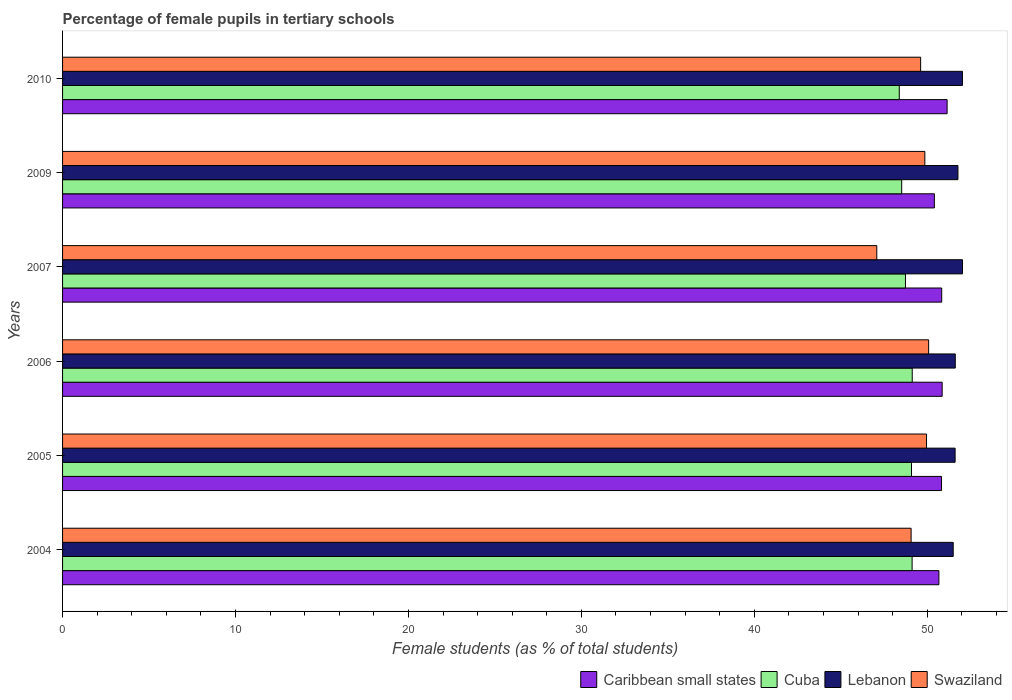How many different coloured bars are there?
Offer a very short reply. 4. How many bars are there on the 4th tick from the bottom?
Provide a succinct answer. 4. In how many cases, is the number of bars for a given year not equal to the number of legend labels?
Provide a succinct answer. 0. What is the percentage of female pupils in tertiary schools in Swaziland in 2006?
Your answer should be very brief. 50.08. Across all years, what is the maximum percentage of female pupils in tertiary schools in Cuba?
Your response must be concise. 49.13. Across all years, what is the minimum percentage of female pupils in tertiary schools in Caribbean small states?
Your answer should be compact. 50.41. In which year was the percentage of female pupils in tertiary schools in Swaziland maximum?
Your answer should be very brief. 2006. What is the total percentage of female pupils in tertiary schools in Lebanon in the graph?
Keep it short and to the point. 310.57. What is the difference between the percentage of female pupils in tertiary schools in Caribbean small states in 2004 and that in 2010?
Keep it short and to the point. -0.47. What is the difference between the percentage of female pupils in tertiary schools in Swaziland in 2010 and the percentage of female pupils in tertiary schools in Cuba in 2005?
Your answer should be compact. 0.53. What is the average percentage of female pupils in tertiary schools in Lebanon per year?
Make the answer very short. 51.76. In the year 2007, what is the difference between the percentage of female pupils in tertiary schools in Cuba and percentage of female pupils in tertiary schools in Caribbean small states?
Provide a short and direct response. -2.09. In how many years, is the percentage of female pupils in tertiary schools in Cuba greater than 36 %?
Offer a very short reply. 6. What is the ratio of the percentage of female pupils in tertiary schools in Caribbean small states in 2005 to that in 2010?
Make the answer very short. 0.99. Is the percentage of female pupils in tertiary schools in Cuba in 2005 less than that in 2010?
Provide a succinct answer. No. Is the difference between the percentage of female pupils in tertiary schools in Cuba in 2009 and 2010 greater than the difference between the percentage of female pupils in tertiary schools in Caribbean small states in 2009 and 2010?
Offer a terse response. Yes. What is the difference between the highest and the second highest percentage of female pupils in tertiary schools in Lebanon?
Offer a very short reply. 0. What is the difference between the highest and the lowest percentage of female pupils in tertiary schools in Swaziland?
Provide a succinct answer. 3. In how many years, is the percentage of female pupils in tertiary schools in Lebanon greater than the average percentage of female pupils in tertiary schools in Lebanon taken over all years?
Your answer should be very brief. 3. Is it the case that in every year, the sum of the percentage of female pupils in tertiary schools in Lebanon and percentage of female pupils in tertiary schools in Caribbean small states is greater than the sum of percentage of female pupils in tertiary schools in Cuba and percentage of female pupils in tertiary schools in Swaziland?
Provide a short and direct response. Yes. What does the 3rd bar from the top in 2005 represents?
Offer a terse response. Cuba. What does the 1st bar from the bottom in 2005 represents?
Give a very brief answer. Caribbean small states. Are all the bars in the graph horizontal?
Give a very brief answer. Yes. How many years are there in the graph?
Your answer should be compact. 6. What is the difference between two consecutive major ticks on the X-axis?
Offer a terse response. 10. Where does the legend appear in the graph?
Offer a very short reply. Bottom right. What is the title of the graph?
Make the answer very short. Percentage of female pupils in tertiary schools. Does "Gambia, The" appear as one of the legend labels in the graph?
Offer a very short reply. No. What is the label or title of the X-axis?
Ensure brevity in your answer.  Female students (as % of total students). What is the label or title of the Y-axis?
Your response must be concise. Years. What is the Female students (as % of total students) of Caribbean small states in 2004?
Your answer should be very brief. 50.67. What is the Female students (as % of total students) in Cuba in 2004?
Your response must be concise. 49.12. What is the Female students (as % of total students) of Lebanon in 2004?
Offer a very short reply. 51.5. What is the Female students (as % of total students) of Swaziland in 2004?
Your answer should be compact. 49.06. What is the Female students (as % of total students) in Caribbean small states in 2005?
Offer a very short reply. 50.82. What is the Female students (as % of total students) in Cuba in 2005?
Ensure brevity in your answer.  49.09. What is the Female students (as % of total students) of Lebanon in 2005?
Give a very brief answer. 51.61. What is the Female students (as % of total students) of Swaziland in 2005?
Ensure brevity in your answer.  49.95. What is the Female students (as % of total students) of Caribbean small states in 2006?
Provide a succinct answer. 50.86. What is the Female students (as % of total students) in Cuba in 2006?
Your answer should be very brief. 49.13. What is the Female students (as % of total students) of Lebanon in 2006?
Your response must be concise. 51.62. What is the Female students (as % of total students) in Swaziland in 2006?
Give a very brief answer. 50.08. What is the Female students (as % of total students) of Caribbean small states in 2007?
Your answer should be very brief. 50.83. What is the Female students (as % of total students) in Cuba in 2007?
Offer a terse response. 48.74. What is the Female students (as % of total students) of Lebanon in 2007?
Make the answer very short. 52.04. What is the Female students (as % of total students) of Swaziland in 2007?
Give a very brief answer. 47.08. What is the Female students (as % of total students) of Caribbean small states in 2009?
Make the answer very short. 50.41. What is the Female students (as % of total students) in Cuba in 2009?
Your answer should be compact. 48.52. What is the Female students (as % of total students) in Lebanon in 2009?
Keep it short and to the point. 51.77. What is the Female students (as % of total students) of Swaziland in 2009?
Your answer should be compact. 49.86. What is the Female students (as % of total students) in Caribbean small states in 2010?
Provide a short and direct response. 51.15. What is the Female students (as % of total students) in Cuba in 2010?
Give a very brief answer. 48.38. What is the Female students (as % of total students) of Lebanon in 2010?
Give a very brief answer. 52.03. What is the Female students (as % of total students) of Swaziland in 2010?
Make the answer very short. 49.62. Across all years, what is the maximum Female students (as % of total students) of Caribbean small states?
Make the answer very short. 51.15. Across all years, what is the maximum Female students (as % of total students) of Cuba?
Provide a short and direct response. 49.13. Across all years, what is the maximum Female students (as % of total students) in Lebanon?
Ensure brevity in your answer.  52.04. Across all years, what is the maximum Female students (as % of total students) in Swaziland?
Offer a terse response. 50.08. Across all years, what is the minimum Female students (as % of total students) of Caribbean small states?
Give a very brief answer. 50.41. Across all years, what is the minimum Female students (as % of total students) in Cuba?
Make the answer very short. 48.38. Across all years, what is the minimum Female students (as % of total students) in Lebanon?
Give a very brief answer. 51.5. Across all years, what is the minimum Female students (as % of total students) in Swaziland?
Keep it short and to the point. 47.08. What is the total Female students (as % of total students) in Caribbean small states in the graph?
Make the answer very short. 304.75. What is the total Female students (as % of total students) in Cuba in the graph?
Ensure brevity in your answer.  292.98. What is the total Female students (as % of total students) of Lebanon in the graph?
Your response must be concise. 310.57. What is the total Female students (as % of total students) of Swaziland in the graph?
Provide a succinct answer. 295.66. What is the difference between the Female students (as % of total students) in Caribbean small states in 2004 and that in 2005?
Provide a succinct answer. -0.15. What is the difference between the Female students (as % of total students) in Cuba in 2004 and that in 2005?
Give a very brief answer. 0.04. What is the difference between the Female students (as % of total students) of Lebanon in 2004 and that in 2005?
Your answer should be compact. -0.11. What is the difference between the Female students (as % of total students) in Swaziland in 2004 and that in 2005?
Offer a terse response. -0.89. What is the difference between the Female students (as % of total students) of Caribbean small states in 2004 and that in 2006?
Provide a succinct answer. -0.19. What is the difference between the Female students (as % of total students) in Cuba in 2004 and that in 2006?
Your response must be concise. -0.01. What is the difference between the Female students (as % of total students) in Lebanon in 2004 and that in 2006?
Keep it short and to the point. -0.12. What is the difference between the Female students (as % of total students) in Swaziland in 2004 and that in 2006?
Provide a short and direct response. -1.01. What is the difference between the Female students (as % of total students) in Caribbean small states in 2004 and that in 2007?
Make the answer very short. -0.16. What is the difference between the Female students (as % of total students) of Cuba in 2004 and that in 2007?
Make the answer very short. 0.38. What is the difference between the Female students (as % of total students) of Lebanon in 2004 and that in 2007?
Provide a succinct answer. -0.54. What is the difference between the Female students (as % of total students) in Swaziland in 2004 and that in 2007?
Give a very brief answer. 1.98. What is the difference between the Female students (as % of total students) in Caribbean small states in 2004 and that in 2009?
Ensure brevity in your answer.  0.26. What is the difference between the Female students (as % of total students) in Cuba in 2004 and that in 2009?
Offer a very short reply. 0.6. What is the difference between the Female students (as % of total students) in Lebanon in 2004 and that in 2009?
Offer a terse response. -0.27. What is the difference between the Female students (as % of total students) in Swaziland in 2004 and that in 2009?
Your answer should be compact. -0.79. What is the difference between the Female students (as % of total students) in Caribbean small states in 2004 and that in 2010?
Give a very brief answer. -0.47. What is the difference between the Female students (as % of total students) of Cuba in 2004 and that in 2010?
Offer a very short reply. 0.74. What is the difference between the Female students (as % of total students) of Lebanon in 2004 and that in 2010?
Ensure brevity in your answer.  -0.53. What is the difference between the Female students (as % of total students) in Swaziland in 2004 and that in 2010?
Give a very brief answer. -0.55. What is the difference between the Female students (as % of total students) in Caribbean small states in 2005 and that in 2006?
Provide a short and direct response. -0.04. What is the difference between the Female students (as % of total students) of Cuba in 2005 and that in 2006?
Your answer should be very brief. -0.04. What is the difference between the Female students (as % of total students) in Lebanon in 2005 and that in 2006?
Ensure brevity in your answer.  -0.01. What is the difference between the Female students (as % of total students) of Swaziland in 2005 and that in 2006?
Offer a very short reply. -0.12. What is the difference between the Female students (as % of total students) of Caribbean small states in 2005 and that in 2007?
Your answer should be very brief. -0.01. What is the difference between the Female students (as % of total students) in Cuba in 2005 and that in 2007?
Make the answer very short. 0.35. What is the difference between the Female students (as % of total students) of Lebanon in 2005 and that in 2007?
Offer a terse response. -0.43. What is the difference between the Female students (as % of total students) in Swaziland in 2005 and that in 2007?
Provide a succinct answer. 2.87. What is the difference between the Female students (as % of total students) in Caribbean small states in 2005 and that in 2009?
Provide a succinct answer. 0.41. What is the difference between the Female students (as % of total students) in Cuba in 2005 and that in 2009?
Give a very brief answer. 0.57. What is the difference between the Female students (as % of total students) in Lebanon in 2005 and that in 2009?
Keep it short and to the point. -0.16. What is the difference between the Female students (as % of total students) in Swaziland in 2005 and that in 2009?
Keep it short and to the point. 0.1. What is the difference between the Female students (as % of total students) in Caribbean small states in 2005 and that in 2010?
Offer a very short reply. -0.32. What is the difference between the Female students (as % of total students) in Cuba in 2005 and that in 2010?
Your response must be concise. 0.71. What is the difference between the Female students (as % of total students) of Lebanon in 2005 and that in 2010?
Make the answer very short. -0.42. What is the difference between the Female students (as % of total students) in Swaziland in 2005 and that in 2010?
Your response must be concise. 0.34. What is the difference between the Female students (as % of total students) in Caribbean small states in 2006 and that in 2007?
Provide a short and direct response. 0.03. What is the difference between the Female students (as % of total students) of Cuba in 2006 and that in 2007?
Give a very brief answer. 0.39. What is the difference between the Female students (as % of total students) in Lebanon in 2006 and that in 2007?
Provide a succinct answer. -0.42. What is the difference between the Female students (as % of total students) of Swaziland in 2006 and that in 2007?
Your answer should be very brief. 3. What is the difference between the Female students (as % of total students) of Caribbean small states in 2006 and that in 2009?
Offer a terse response. 0.45. What is the difference between the Female students (as % of total students) in Cuba in 2006 and that in 2009?
Keep it short and to the point. 0.61. What is the difference between the Female students (as % of total students) of Lebanon in 2006 and that in 2009?
Make the answer very short. -0.15. What is the difference between the Female students (as % of total students) in Swaziland in 2006 and that in 2009?
Make the answer very short. 0.22. What is the difference between the Female students (as % of total students) of Caribbean small states in 2006 and that in 2010?
Keep it short and to the point. -0.29. What is the difference between the Female students (as % of total students) in Cuba in 2006 and that in 2010?
Your response must be concise. 0.75. What is the difference between the Female students (as % of total students) of Lebanon in 2006 and that in 2010?
Your response must be concise. -0.41. What is the difference between the Female students (as % of total students) in Swaziland in 2006 and that in 2010?
Make the answer very short. 0.46. What is the difference between the Female students (as % of total students) of Caribbean small states in 2007 and that in 2009?
Your response must be concise. 0.42. What is the difference between the Female students (as % of total students) of Cuba in 2007 and that in 2009?
Your answer should be very brief. 0.22. What is the difference between the Female students (as % of total students) in Lebanon in 2007 and that in 2009?
Make the answer very short. 0.26. What is the difference between the Female students (as % of total students) of Swaziland in 2007 and that in 2009?
Your answer should be compact. -2.78. What is the difference between the Female students (as % of total students) of Caribbean small states in 2007 and that in 2010?
Provide a succinct answer. -0.31. What is the difference between the Female students (as % of total students) in Cuba in 2007 and that in 2010?
Keep it short and to the point. 0.36. What is the difference between the Female students (as % of total students) of Lebanon in 2007 and that in 2010?
Give a very brief answer. 0. What is the difference between the Female students (as % of total students) in Swaziland in 2007 and that in 2010?
Ensure brevity in your answer.  -2.53. What is the difference between the Female students (as % of total students) of Caribbean small states in 2009 and that in 2010?
Make the answer very short. -0.74. What is the difference between the Female students (as % of total students) in Cuba in 2009 and that in 2010?
Give a very brief answer. 0.14. What is the difference between the Female students (as % of total students) of Lebanon in 2009 and that in 2010?
Keep it short and to the point. -0.26. What is the difference between the Female students (as % of total students) of Swaziland in 2009 and that in 2010?
Provide a short and direct response. 0.24. What is the difference between the Female students (as % of total students) of Caribbean small states in 2004 and the Female students (as % of total students) of Cuba in 2005?
Provide a short and direct response. 1.58. What is the difference between the Female students (as % of total students) in Caribbean small states in 2004 and the Female students (as % of total students) in Lebanon in 2005?
Keep it short and to the point. -0.94. What is the difference between the Female students (as % of total students) in Caribbean small states in 2004 and the Female students (as % of total students) in Swaziland in 2005?
Make the answer very short. 0.72. What is the difference between the Female students (as % of total students) of Cuba in 2004 and the Female students (as % of total students) of Lebanon in 2005?
Your answer should be very brief. -2.49. What is the difference between the Female students (as % of total students) of Cuba in 2004 and the Female students (as % of total students) of Swaziland in 2005?
Your answer should be very brief. -0.83. What is the difference between the Female students (as % of total students) of Lebanon in 2004 and the Female students (as % of total students) of Swaziland in 2005?
Keep it short and to the point. 1.54. What is the difference between the Female students (as % of total students) in Caribbean small states in 2004 and the Female students (as % of total students) in Cuba in 2006?
Provide a succinct answer. 1.54. What is the difference between the Female students (as % of total students) of Caribbean small states in 2004 and the Female students (as % of total students) of Lebanon in 2006?
Give a very brief answer. -0.95. What is the difference between the Female students (as % of total students) of Caribbean small states in 2004 and the Female students (as % of total students) of Swaziland in 2006?
Ensure brevity in your answer.  0.59. What is the difference between the Female students (as % of total students) of Cuba in 2004 and the Female students (as % of total students) of Lebanon in 2006?
Offer a terse response. -2.5. What is the difference between the Female students (as % of total students) in Cuba in 2004 and the Female students (as % of total students) in Swaziland in 2006?
Your answer should be very brief. -0.96. What is the difference between the Female students (as % of total students) in Lebanon in 2004 and the Female students (as % of total students) in Swaziland in 2006?
Provide a succinct answer. 1.42. What is the difference between the Female students (as % of total students) of Caribbean small states in 2004 and the Female students (as % of total students) of Cuba in 2007?
Offer a very short reply. 1.93. What is the difference between the Female students (as % of total students) in Caribbean small states in 2004 and the Female students (as % of total students) in Lebanon in 2007?
Your answer should be very brief. -1.36. What is the difference between the Female students (as % of total students) in Caribbean small states in 2004 and the Female students (as % of total students) in Swaziland in 2007?
Offer a very short reply. 3.59. What is the difference between the Female students (as % of total students) in Cuba in 2004 and the Female students (as % of total students) in Lebanon in 2007?
Provide a short and direct response. -2.91. What is the difference between the Female students (as % of total students) in Cuba in 2004 and the Female students (as % of total students) in Swaziland in 2007?
Your response must be concise. 2.04. What is the difference between the Female students (as % of total students) in Lebanon in 2004 and the Female students (as % of total students) in Swaziland in 2007?
Your answer should be compact. 4.42. What is the difference between the Female students (as % of total students) in Caribbean small states in 2004 and the Female students (as % of total students) in Cuba in 2009?
Your answer should be very brief. 2.15. What is the difference between the Female students (as % of total students) in Caribbean small states in 2004 and the Female students (as % of total students) in Lebanon in 2009?
Ensure brevity in your answer.  -1.1. What is the difference between the Female students (as % of total students) in Caribbean small states in 2004 and the Female students (as % of total students) in Swaziland in 2009?
Ensure brevity in your answer.  0.81. What is the difference between the Female students (as % of total students) in Cuba in 2004 and the Female students (as % of total students) in Lebanon in 2009?
Provide a short and direct response. -2.65. What is the difference between the Female students (as % of total students) of Cuba in 2004 and the Female students (as % of total students) of Swaziland in 2009?
Your answer should be compact. -0.74. What is the difference between the Female students (as % of total students) of Lebanon in 2004 and the Female students (as % of total students) of Swaziland in 2009?
Provide a succinct answer. 1.64. What is the difference between the Female students (as % of total students) in Caribbean small states in 2004 and the Female students (as % of total students) in Cuba in 2010?
Offer a terse response. 2.29. What is the difference between the Female students (as % of total students) of Caribbean small states in 2004 and the Female students (as % of total students) of Lebanon in 2010?
Give a very brief answer. -1.36. What is the difference between the Female students (as % of total students) in Caribbean small states in 2004 and the Female students (as % of total students) in Swaziland in 2010?
Your answer should be compact. 1.06. What is the difference between the Female students (as % of total students) in Cuba in 2004 and the Female students (as % of total students) in Lebanon in 2010?
Your answer should be compact. -2.91. What is the difference between the Female students (as % of total students) of Cuba in 2004 and the Female students (as % of total students) of Swaziland in 2010?
Provide a short and direct response. -0.49. What is the difference between the Female students (as % of total students) of Lebanon in 2004 and the Female students (as % of total students) of Swaziland in 2010?
Your answer should be very brief. 1.88. What is the difference between the Female students (as % of total students) in Caribbean small states in 2005 and the Female students (as % of total students) in Cuba in 2006?
Your answer should be compact. 1.69. What is the difference between the Female students (as % of total students) in Caribbean small states in 2005 and the Female students (as % of total students) in Lebanon in 2006?
Provide a short and direct response. -0.8. What is the difference between the Female students (as % of total students) of Caribbean small states in 2005 and the Female students (as % of total students) of Swaziland in 2006?
Your answer should be compact. 0.74. What is the difference between the Female students (as % of total students) of Cuba in 2005 and the Female students (as % of total students) of Lebanon in 2006?
Give a very brief answer. -2.53. What is the difference between the Female students (as % of total students) of Cuba in 2005 and the Female students (as % of total students) of Swaziland in 2006?
Provide a succinct answer. -0.99. What is the difference between the Female students (as % of total students) in Lebanon in 2005 and the Female students (as % of total students) in Swaziland in 2006?
Offer a very short reply. 1.53. What is the difference between the Female students (as % of total students) of Caribbean small states in 2005 and the Female students (as % of total students) of Cuba in 2007?
Offer a very short reply. 2.08. What is the difference between the Female students (as % of total students) of Caribbean small states in 2005 and the Female students (as % of total students) of Lebanon in 2007?
Your answer should be very brief. -1.21. What is the difference between the Female students (as % of total students) in Caribbean small states in 2005 and the Female students (as % of total students) in Swaziland in 2007?
Offer a very short reply. 3.74. What is the difference between the Female students (as % of total students) in Cuba in 2005 and the Female students (as % of total students) in Lebanon in 2007?
Keep it short and to the point. -2.95. What is the difference between the Female students (as % of total students) in Cuba in 2005 and the Female students (as % of total students) in Swaziland in 2007?
Make the answer very short. 2.01. What is the difference between the Female students (as % of total students) of Lebanon in 2005 and the Female students (as % of total students) of Swaziland in 2007?
Your answer should be compact. 4.53. What is the difference between the Female students (as % of total students) in Caribbean small states in 2005 and the Female students (as % of total students) in Cuba in 2009?
Make the answer very short. 2.3. What is the difference between the Female students (as % of total students) of Caribbean small states in 2005 and the Female students (as % of total students) of Lebanon in 2009?
Your answer should be compact. -0.95. What is the difference between the Female students (as % of total students) of Cuba in 2005 and the Female students (as % of total students) of Lebanon in 2009?
Ensure brevity in your answer.  -2.69. What is the difference between the Female students (as % of total students) of Cuba in 2005 and the Female students (as % of total students) of Swaziland in 2009?
Your response must be concise. -0.77. What is the difference between the Female students (as % of total students) in Lebanon in 2005 and the Female students (as % of total students) in Swaziland in 2009?
Your answer should be very brief. 1.75. What is the difference between the Female students (as % of total students) of Caribbean small states in 2005 and the Female students (as % of total students) of Cuba in 2010?
Keep it short and to the point. 2.44. What is the difference between the Female students (as % of total students) of Caribbean small states in 2005 and the Female students (as % of total students) of Lebanon in 2010?
Provide a succinct answer. -1.21. What is the difference between the Female students (as % of total students) in Caribbean small states in 2005 and the Female students (as % of total students) in Swaziland in 2010?
Offer a very short reply. 1.21. What is the difference between the Female students (as % of total students) of Cuba in 2005 and the Female students (as % of total students) of Lebanon in 2010?
Keep it short and to the point. -2.95. What is the difference between the Female students (as % of total students) in Cuba in 2005 and the Female students (as % of total students) in Swaziland in 2010?
Provide a short and direct response. -0.53. What is the difference between the Female students (as % of total students) in Lebanon in 2005 and the Female students (as % of total students) in Swaziland in 2010?
Offer a very short reply. 1.99. What is the difference between the Female students (as % of total students) in Caribbean small states in 2006 and the Female students (as % of total students) in Cuba in 2007?
Your response must be concise. 2.12. What is the difference between the Female students (as % of total students) in Caribbean small states in 2006 and the Female students (as % of total students) in Lebanon in 2007?
Your response must be concise. -1.18. What is the difference between the Female students (as % of total students) in Caribbean small states in 2006 and the Female students (as % of total students) in Swaziland in 2007?
Give a very brief answer. 3.78. What is the difference between the Female students (as % of total students) in Cuba in 2006 and the Female students (as % of total students) in Lebanon in 2007?
Provide a short and direct response. -2.91. What is the difference between the Female students (as % of total students) of Cuba in 2006 and the Female students (as % of total students) of Swaziland in 2007?
Give a very brief answer. 2.05. What is the difference between the Female students (as % of total students) of Lebanon in 2006 and the Female students (as % of total students) of Swaziland in 2007?
Provide a succinct answer. 4.54. What is the difference between the Female students (as % of total students) in Caribbean small states in 2006 and the Female students (as % of total students) in Cuba in 2009?
Your response must be concise. 2.34. What is the difference between the Female students (as % of total students) in Caribbean small states in 2006 and the Female students (as % of total students) in Lebanon in 2009?
Provide a short and direct response. -0.91. What is the difference between the Female students (as % of total students) in Cuba in 2006 and the Female students (as % of total students) in Lebanon in 2009?
Make the answer very short. -2.64. What is the difference between the Female students (as % of total students) of Cuba in 2006 and the Female students (as % of total students) of Swaziland in 2009?
Keep it short and to the point. -0.73. What is the difference between the Female students (as % of total students) in Lebanon in 2006 and the Female students (as % of total students) in Swaziland in 2009?
Ensure brevity in your answer.  1.76. What is the difference between the Female students (as % of total students) in Caribbean small states in 2006 and the Female students (as % of total students) in Cuba in 2010?
Your answer should be compact. 2.48. What is the difference between the Female students (as % of total students) of Caribbean small states in 2006 and the Female students (as % of total students) of Lebanon in 2010?
Your answer should be very brief. -1.17. What is the difference between the Female students (as % of total students) of Caribbean small states in 2006 and the Female students (as % of total students) of Swaziland in 2010?
Your answer should be compact. 1.24. What is the difference between the Female students (as % of total students) of Cuba in 2006 and the Female students (as % of total students) of Lebanon in 2010?
Your answer should be compact. -2.9. What is the difference between the Female students (as % of total students) of Cuba in 2006 and the Female students (as % of total students) of Swaziland in 2010?
Your answer should be very brief. -0.49. What is the difference between the Female students (as % of total students) in Lebanon in 2006 and the Female students (as % of total students) in Swaziland in 2010?
Your answer should be compact. 2. What is the difference between the Female students (as % of total students) of Caribbean small states in 2007 and the Female students (as % of total students) of Cuba in 2009?
Your answer should be very brief. 2.31. What is the difference between the Female students (as % of total students) of Caribbean small states in 2007 and the Female students (as % of total students) of Lebanon in 2009?
Your response must be concise. -0.94. What is the difference between the Female students (as % of total students) in Caribbean small states in 2007 and the Female students (as % of total students) in Swaziland in 2009?
Keep it short and to the point. 0.97. What is the difference between the Female students (as % of total students) in Cuba in 2007 and the Female students (as % of total students) in Lebanon in 2009?
Provide a succinct answer. -3.03. What is the difference between the Female students (as % of total students) in Cuba in 2007 and the Female students (as % of total students) in Swaziland in 2009?
Ensure brevity in your answer.  -1.12. What is the difference between the Female students (as % of total students) in Lebanon in 2007 and the Female students (as % of total students) in Swaziland in 2009?
Keep it short and to the point. 2.18. What is the difference between the Female students (as % of total students) in Caribbean small states in 2007 and the Female students (as % of total students) in Cuba in 2010?
Give a very brief answer. 2.45. What is the difference between the Female students (as % of total students) in Caribbean small states in 2007 and the Female students (as % of total students) in Lebanon in 2010?
Offer a very short reply. -1.2. What is the difference between the Female students (as % of total students) in Caribbean small states in 2007 and the Female students (as % of total students) in Swaziland in 2010?
Offer a terse response. 1.22. What is the difference between the Female students (as % of total students) in Cuba in 2007 and the Female students (as % of total students) in Lebanon in 2010?
Offer a terse response. -3.29. What is the difference between the Female students (as % of total students) of Cuba in 2007 and the Female students (as % of total students) of Swaziland in 2010?
Keep it short and to the point. -0.88. What is the difference between the Female students (as % of total students) of Lebanon in 2007 and the Female students (as % of total students) of Swaziland in 2010?
Keep it short and to the point. 2.42. What is the difference between the Female students (as % of total students) in Caribbean small states in 2009 and the Female students (as % of total students) in Cuba in 2010?
Provide a succinct answer. 2.03. What is the difference between the Female students (as % of total students) in Caribbean small states in 2009 and the Female students (as % of total students) in Lebanon in 2010?
Your answer should be very brief. -1.62. What is the difference between the Female students (as % of total students) in Caribbean small states in 2009 and the Female students (as % of total students) in Swaziland in 2010?
Your answer should be compact. 0.79. What is the difference between the Female students (as % of total students) of Cuba in 2009 and the Female students (as % of total students) of Lebanon in 2010?
Make the answer very short. -3.51. What is the difference between the Female students (as % of total students) of Cuba in 2009 and the Female students (as % of total students) of Swaziland in 2010?
Provide a succinct answer. -1.09. What is the difference between the Female students (as % of total students) of Lebanon in 2009 and the Female students (as % of total students) of Swaziland in 2010?
Provide a succinct answer. 2.16. What is the average Female students (as % of total students) of Caribbean small states per year?
Your answer should be very brief. 50.79. What is the average Female students (as % of total students) in Cuba per year?
Offer a very short reply. 48.83. What is the average Female students (as % of total students) in Lebanon per year?
Your answer should be compact. 51.76. What is the average Female students (as % of total students) in Swaziland per year?
Ensure brevity in your answer.  49.28. In the year 2004, what is the difference between the Female students (as % of total students) of Caribbean small states and Female students (as % of total students) of Cuba?
Your answer should be compact. 1.55. In the year 2004, what is the difference between the Female students (as % of total students) in Caribbean small states and Female students (as % of total students) in Lebanon?
Offer a terse response. -0.83. In the year 2004, what is the difference between the Female students (as % of total students) in Caribbean small states and Female students (as % of total students) in Swaziland?
Your response must be concise. 1.61. In the year 2004, what is the difference between the Female students (as % of total students) of Cuba and Female students (as % of total students) of Lebanon?
Offer a terse response. -2.38. In the year 2004, what is the difference between the Female students (as % of total students) in Cuba and Female students (as % of total students) in Swaziland?
Your answer should be compact. 0.06. In the year 2004, what is the difference between the Female students (as % of total students) in Lebanon and Female students (as % of total students) in Swaziland?
Your answer should be compact. 2.43. In the year 2005, what is the difference between the Female students (as % of total students) of Caribbean small states and Female students (as % of total students) of Cuba?
Provide a succinct answer. 1.73. In the year 2005, what is the difference between the Female students (as % of total students) in Caribbean small states and Female students (as % of total students) in Lebanon?
Provide a short and direct response. -0.79. In the year 2005, what is the difference between the Female students (as % of total students) of Caribbean small states and Female students (as % of total students) of Swaziland?
Offer a terse response. 0.87. In the year 2005, what is the difference between the Female students (as % of total students) of Cuba and Female students (as % of total students) of Lebanon?
Offer a very short reply. -2.52. In the year 2005, what is the difference between the Female students (as % of total students) in Cuba and Female students (as % of total students) in Swaziland?
Provide a short and direct response. -0.87. In the year 2005, what is the difference between the Female students (as % of total students) in Lebanon and Female students (as % of total students) in Swaziland?
Provide a short and direct response. 1.65. In the year 2006, what is the difference between the Female students (as % of total students) of Caribbean small states and Female students (as % of total students) of Cuba?
Give a very brief answer. 1.73. In the year 2006, what is the difference between the Female students (as % of total students) of Caribbean small states and Female students (as % of total students) of Lebanon?
Your answer should be compact. -0.76. In the year 2006, what is the difference between the Female students (as % of total students) of Caribbean small states and Female students (as % of total students) of Swaziland?
Your response must be concise. 0.78. In the year 2006, what is the difference between the Female students (as % of total students) of Cuba and Female students (as % of total students) of Lebanon?
Keep it short and to the point. -2.49. In the year 2006, what is the difference between the Female students (as % of total students) of Cuba and Female students (as % of total students) of Swaziland?
Provide a succinct answer. -0.95. In the year 2006, what is the difference between the Female students (as % of total students) of Lebanon and Female students (as % of total students) of Swaziland?
Offer a very short reply. 1.54. In the year 2007, what is the difference between the Female students (as % of total students) of Caribbean small states and Female students (as % of total students) of Cuba?
Offer a very short reply. 2.09. In the year 2007, what is the difference between the Female students (as % of total students) in Caribbean small states and Female students (as % of total students) in Lebanon?
Ensure brevity in your answer.  -1.2. In the year 2007, what is the difference between the Female students (as % of total students) in Caribbean small states and Female students (as % of total students) in Swaziland?
Give a very brief answer. 3.75. In the year 2007, what is the difference between the Female students (as % of total students) in Cuba and Female students (as % of total students) in Lebanon?
Your response must be concise. -3.3. In the year 2007, what is the difference between the Female students (as % of total students) of Cuba and Female students (as % of total students) of Swaziland?
Make the answer very short. 1.66. In the year 2007, what is the difference between the Female students (as % of total students) in Lebanon and Female students (as % of total students) in Swaziland?
Ensure brevity in your answer.  4.96. In the year 2009, what is the difference between the Female students (as % of total students) of Caribbean small states and Female students (as % of total students) of Cuba?
Your response must be concise. 1.89. In the year 2009, what is the difference between the Female students (as % of total students) of Caribbean small states and Female students (as % of total students) of Lebanon?
Offer a terse response. -1.36. In the year 2009, what is the difference between the Female students (as % of total students) of Caribbean small states and Female students (as % of total students) of Swaziland?
Ensure brevity in your answer.  0.55. In the year 2009, what is the difference between the Female students (as % of total students) of Cuba and Female students (as % of total students) of Lebanon?
Keep it short and to the point. -3.25. In the year 2009, what is the difference between the Female students (as % of total students) of Cuba and Female students (as % of total students) of Swaziland?
Your response must be concise. -1.34. In the year 2009, what is the difference between the Female students (as % of total students) in Lebanon and Female students (as % of total students) in Swaziland?
Offer a very short reply. 1.91. In the year 2010, what is the difference between the Female students (as % of total students) in Caribbean small states and Female students (as % of total students) in Cuba?
Keep it short and to the point. 2.77. In the year 2010, what is the difference between the Female students (as % of total students) in Caribbean small states and Female students (as % of total students) in Lebanon?
Offer a terse response. -0.89. In the year 2010, what is the difference between the Female students (as % of total students) of Caribbean small states and Female students (as % of total students) of Swaziland?
Provide a succinct answer. 1.53. In the year 2010, what is the difference between the Female students (as % of total students) in Cuba and Female students (as % of total students) in Lebanon?
Ensure brevity in your answer.  -3.65. In the year 2010, what is the difference between the Female students (as % of total students) of Cuba and Female students (as % of total students) of Swaziland?
Offer a very short reply. -1.23. In the year 2010, what is the difference between the Female students (as % of total students) of Lebanon and Female students (as % of total students) of Swaziland?
Your response must be concise. 2.42. What is the ratio of the Female students (as % of total students) in Caribbean small states in 2004 to that in 2005?
Your answer should be very brief. 1. What is the ratio of the Female students (as % of total students) of Lebanon in 2004 to that in 2005?
Ensure brevity in your answer.  1. What is the ratio of the Female students (as % of total students) in Swaziland in 2004 to that in 2005?
Offer a terse response. 0.98. What is the ratio of the Female students (as % of total students) in Caribbean small states in 2004 to that in 2006?
Your response must be concise. 1. What is the ratio of the Female students (as % of total students) of Cuba in 2004 to that in 2006?
Make the answer very short. 1. What is the ratio of the Female students (as % of total students) of Lebanon in 2004 to that in 2006?
Give a very brief answer. 1. What is the ratio of the Female students (as % of total students) of Swaziland in 2004 to that in 2006?
Give a very brief answer. 0.98. What is the ratio of the Female students (as % of total students) of Caribbean small states in 2004 to that in 2007?
Your answer should be very brief. 1. What is the ratio of the Female students (as % of total students) in Cuba in 2004 to that in 2007?
Offer a very short reply. 1.01. What is the ratio of the Female students (as % of total students) in Swaziland in 2004 to that in 2007?
Your response must be concise. 1.04. What is the ratio of the Female students (as % of total students) in Caribbean small states in 2004 to that in 2009?
Provide a succinct answer. 1.01. What is the ratio of the Female students (as % of total students) of Cuba in 2004 to that in 2009?
Provide a succinct answer. 1.01. What is the ratio of the Female students (as % of total students) in Swaziland in 2004 to that in 2009?
Provide a succinct answer. 0.98. What is the ratio of the Female students (as % of total students) in Cuba in 2004 to that in 2010?
Offer a very short reply. 1.02. What is the ratio of the Female students (as % of total students) of Swaziland in 2004 to that in 2010?
Make the answer very short. 0.99. What is the ratio of the Female students (as % of total students) of Cuba in 2005 to that in 2006?
Your answer should be very brief. 1. What is the ratio of the Female students (as % of total students) in Lebanon in 2005 to that in 2006?
Keep it short and to the point. 1. What is the ratio of the Female students (as % of total students) in Swaziland in 2005 to that in 2006?
Offer a very short reply. 1. What is the ratio of the Female students (as % of total students) of Caribbean small states in 2005 to that in 2007?
Ensure brevity in your answer.  1. What is the ratio of the Female students (as % of total students) of Swaziland in 2005 to that in 2007?
Your answer should be very brief. 1.06. What is the ratio of the Female students (as % of total students) in Caribbean small states in 2005 to that in 2009?
Keep it short and to the point. 1.01. What is the ratio of the Female students (as % of total students) in Cuba in 2005 to that in 2009?
Ensure brevity in your answer.  1.01. What is the ratio of the Female students (as % of total students) in Caribbean small states in 2005 to that in 2010?
Offer a terse response. 0.99. What is the ratio of the Female students (as % of total students) of Cuba in 2005 to that in 2010?
Ensure brevity in your answer.  1.01. What is the ratio of the Female students (as % of total students) in Swaziland in 2005 to that in 2010?
Make the answer very short. 1.01. What is the ratio of the Female students (as % of total students) in Swaziland in 2006 to that in 2007?
Offer a terse response. 1.06. What is the ratio of the Female students (as % of total students) in Caribbean small states in 2006 to that in 2009?
Your answer should be very brief. 1.01. What is the ratio of the Female students (as % of total students) of Cuba in 2006 to that in 2009?
Make the answer very short. 1.01. What is the ratio of the Female students (as % of total students) of Lebanon in 2006 to that in 2009?
Provide a short and direct response. 1. What is the ratio of the Female students (as % of total students) in Swaziland in 2006 to that in 2009?
Give a very brief answer. 1. What is the ratio of the Female students (as % of total students) in Cuba in 2006 to that in 2010?
Your answer should be compact. 1.02. What is the ratio of the Female students (as % of total students) of Lebanon in 2006 to that in 2010?
Make the answer very short. 0.99. What is the ratio of the Female students (as % of total students) of Swaziland in 2006 to that in 2010?
Keep it short and to the point. 1.01. What is the ratio of the Female students (as % of total students) of Caribbean small states in 2007 to that in 2009?
Offer a very short reply. 1.01. What is the ratio of the Female students (as % of total students) of Cuba in 2007 to that in 2009?
Provide a succinct answer. 1. What is the ratio of the Female students (as % of total students) in Lebanon in 2007 to that in 2009?
Ensure brevity in your answer.  1.01. What is the ratio of the Female students (as % of total students) of Swaziland in 2007 to that in 2009?
Your response must be concise. 0.94. What is the ratio of the Female students (as % of total students) of Cuba in 2007 to that in 2010?
Provide a succinct answer. 1.01. What is the ratio of the Female students (as % of total students) of Swaziland in 2007 to that in 2010?
Your answer should be compact. 0.95. What is the ratio of the Female students (as % of total students) in Caribbean small states in 2009 to that in 2010?
Give a very brief answer. 0.99. What is the ratio of the Female students (as % of total students) of Lebanon in 2009 to that in 2010?
Provide a short and direct response. 0.99. What is the ratio of the Female students (as % of total students) of Swaziland in 2009 to that in 2010?
Make the answer very short. 1. What is the difference between the highest and the second highest Female students (as % of total students) of Caribbean small states?
Offer a very short reply. 0.29. What is the difference between the highest and the second highest Female students (as % of total students) in Cuba?
Provide a succinct answer. 0.01. What is the difference between the highest and the second highest Female students (as % of total students) of Lebanon?
Provide a succinct answer. 0. What is the difference between the highest and the second highest Female students (as % of total students) of Swaziland?
Your answer should be compact. 0.12. What is the difference between the highest and the lowest Female students (as % of total students) in Caribbean small states?
Your response must be concise. 0.74. What is the difference between the highest and the lowest Female students (as % of total students) in Cuba?
Your answer should be very brief. 0.75. What is the difference between the highest and the lowest Female students (as % of total students) of Lebanon?
Provide a short and direct response. 0.54. What is the difference between the highest and the lowest Female students (as % of total students) in Swaziland?
Give a very brief answer. 3. 